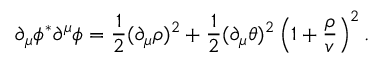Convert formula to latex. <formula><loc_0><loc_0><loc_500><loc_500>\partial _ { \mu } \phi ^ { * } \partial ^ { \mu } \phi = { \frac { 1 } { 2 } } ( \partial _ { \mu } \rho ) ^ { 2 } + { \frac { 1 } { 2 } } ( \partial _ { \mu } \theta ) ^ { 2 } \left ( 1 + { \frac { \rho } { v } } \right ) ^ { 2 } .</formula> 